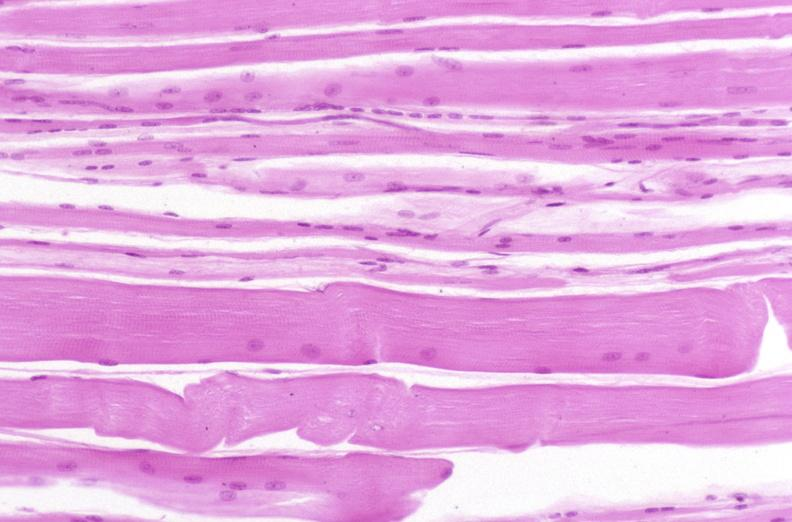what is present?
Answer the question using a single word or phrase. Musculoskeletal 